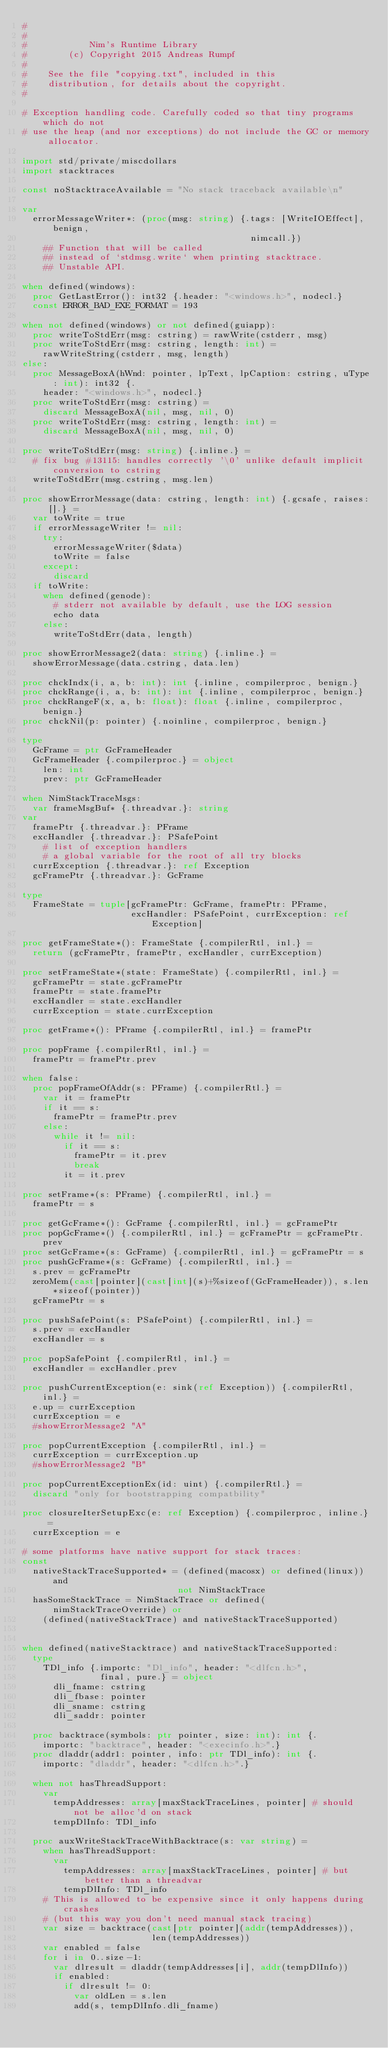Convert code to text. <code><loc_0><loc_0><loc_500><loc_500><_Nim_>#
#
#            Nim's Runtime Library
#        (c) Copyright 2015 Andreas Rumpf
#
#    See the file "copying.txt", included in this
#    distribution, for details about the copyright.
#

# Exception handling code. Carefully coded so that tiny programs which do not
# use the heap (and nor exceptions) do not include the GC or memory allocator.

import std/private/miscdollars
import stacktraces

const noStacktraceAvailable = "No stack traceback available\n"

var
  errorMessageWriter*: (proc(msg: string) {.tags: [WriteIOEffect], benign,
                                            nimcall.})
    ## Function that will be called
    ## instead of `stdmsg.write` when printing stacktrace.
    ## Unstable API.

when defined(windows):
  proc GetLastError(): int32 {.header: "<windows.h>", nodecl.}
  const ERROR_BAD_EXE_FORMAT = 193

when not defined(windows) or not defined(guiapp):
  proc writeToStdErr(msg: cstring) = rawWrite(cstderr, msg)
  proc writeToStdErr(msg: cstring, length: int) =
    rawWriteString(cstderr, msg, length)
else:
  proc MessageBoxA(hWnd: pointer, lpText, lpCaption: cstring, uType: int): int32 {.
    header: "<windows.h>", nodecl.}
  proc writeToStdErr(msg: cstring) =
    discard MessageBoxA(nil, msg, nil, 0)
  proc writeToStdErr(msg: cstring, length: int) =
    discard MessageBoxA(nil, msg, nil, 0)

proc writeToStdErr(msg: string) {.inline.} =
  # fix bug #13115: handles correctly '\0' unlike default implicit conversion to cstring
  writeToStdErr(msg.cstring, msg.len)

proc showErrorMessage(data: cstring, length: int) {.gcsafe, raises: [].} =
  var toWrite = true
  if errorMessageWriter != nil:
    try:
      errorMessageWriter($data)
      toWrite = false
    except:
      discard
  if toWrite:
    when defined(genode):
      # stderr not available by default, use the LOG session
      echo data
    else:
      writeToStdErr(data, length)

proc showErrorMessage2(data: string) {.inline.} =
  showErrorMessage(data.cstring, data.len)

proc chckIndx(i, a, b: int): int {.inline, compilerproc, benign.}
proc chckRange(i, a, b: int): int {.inline, compilerproc, benign.}
proc chckRangeF(x, a, b: float): float {.inline, compilerproc, benign.}
proc chckNil(p: pointer) {.noinline, compilerproc, benign.}

type
  GcFrame = ptr GcFrameHeader
  GcFrameHeader {.compilerproc.} = object
    len: int
    prev: ptr GcFrameHeader

when NimStackTraceMsgs:
  var frameMsgBuf* {.threadvar.}: string
var
  framePtr {.threadvar.}: PFrame
  excHandler {.threadvar.}: PSafePoint
    # list of exception handlers
    # a global variable for the root of all try blocks
  currException {.threadvar.}: ref Exception
  gcFramePtr {.threadvar.}: GcFrame

type
  FrameState = tuple[gcFramePtr: GcFrame, framePtr: PFrame,
                     excHandler: PSafePoint, currException: ref Exception]

proc getFrameState*(): FrameState {.compilerRtl, inl.} =
  return (gcFramePtr, framePtr, excHandler, currException)

proc setFrameState*(state: FrameState) {.compilerRtl, inl.} =
  gcFramePtr = state.gcFramePtr
  framePtr = state.framePtr
  excHandler = state.excHandler
  currException = state.currException

proc getFrame*(): PFrame {.compilerRtl, inl.} = framePtr

proc popFrame {.compilerRtl, inl.} =
  framePtr = framePtr.prev

when false:
  proc popFrameOfAddr(s: PFrame) {.compilerRtl.} =
    var it = framePtr
    if it == s:
      framePtr = framePtr.prev
    else:
      while it != nil:
        if it == s:
          framePtr = it.prev
          break
        it = it.prev

proc setFrame*(s: PFrame) {.compilerRtl, inl.} =
  framePtr = s

proc getGcFrame*(): GcFrame {.compilerRtl, inl.} = gcFramePtr
proc popGcFrame*() {.compilerRtl, inl.} = gcFramePtr = gcFramePtr.prev
proc setGcFrame*(s: GcFrame) {.compilerRtl, inl.} = gcFramePtr = s
proc pushGcFrame*(s: GcFrame) {.compilerRtl, inl.} =
  s.prev = gcFramePtr
  zeroMem(cast[pointer](cast[int](s)+%sizeof(GcFrameHeader)), s.len*sizeof(pointer))
  gcFramePtr = s

proc pushSafePoint(s: PSafePoint) {.compilerRtl, inl.} =
  s.prev = excHandler
  excHandler = s

proc popSafePoint {.compilerRtl, inl.} =
  excHandler = excHandler.prev

proc pushCurrentException(e: sink(ref Exception)) {.compilerRtl, inl.} =
  e.up = currException
  currException = e
  #showErrorMessage2 "A"

proc popCurrentException {.compilerRtl, inl.} =
  currException = currException.up
  #showErrorMessage2 "B"

proc popCurrentExceptionEx(id: uint) {.compilerRtl.} =
  discard "only for bootstrapping compatbility"

proc closureIterSetupExc(e: ref Exception) {.compilerproc, inline.} =
  currException = e

# some platforms have native support for stack traces:
const
  nativeStackTraceSupported* = (defined(macosx) or defined(linux)) and
                              not NimStackTrace
  hasSomeStackTrace = NimStackTrace or defined(nimStackTraceOverride) or
    (defined(nativeStackTrace) and nativeStackTraceSupported)


when defined(nativeStacktrace) and nativeStackTraceSupported:
  type
    TDl_info {.importc: "Dl_info", header: "<dlfcn.h>",
               final, pure.} = object
      dli_fname: cstring
      dli_fbase: pointer
      dli_sname: cstring
      dli_saddr: pointer

  proc backtrace(symbols: ptr pointer, size: int): int {.
    importc: "backtrace", header: "<execinfo.h>".}
  proc dladdr(addr1: pointer, info: ptr TDl_info): int {.
    importc: "dladdr", header: "<dlfcn.h>".}

  when not hasThreadSupport:
    var
      tempAddresses: array[maxStackTraceLines, pointer] # should not be alloc'd on stack
      tempDlInfo: TDl_info

  proc auxWriteStackTraceWithBacktrace(s: var string) =
    when hasThreadSupport:
      var
        tempAddresses: array[maxStackTraceLines, pointer] # but better than a threadvar
        tempDlInfo: TDl_info
    # This is allowed to be expensive since it only happens during crashes
    # (but this way you don't need manual stack tracing)
    var size = backtrace(cast[ptr pointer](addr(tempAddresses)),
                         len(tempAddresses))
    var enabled = false
    for i in 0..size-1:
      var dlresult = dladdr(tempAddresses[i], addr(tempDlInfo))
      if enabled:
        if dlresult != 0:
          var oldLen = s.len
          add(s, tempDlInfo.dli_fname)</code> 